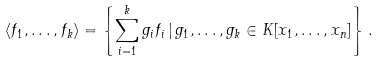Convert formula to latex. <formula><loc_0><loc_0><loc_500><loc_500>\langle f _ { 1 } , \dots , f _ { k } \rangle = \left \{ \sum _ { i = 1 } ^ { k } g _ { i } f _ { i } \, | \, g _ { 1 } , \dots , g _ { k } \in K [ x _ { 1 } , \dots , x _ { n } ] \right \} .</formula> 